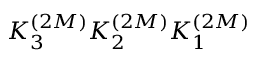<formula> <loc_0><loc_0><loc_500><loc_500>K _ { 3 } ^ { ( 2 M ) } K _ { 2 } ^ { ( 2 M ) } K _ { 1 } ^ { ( 2 M ) }</formula> 